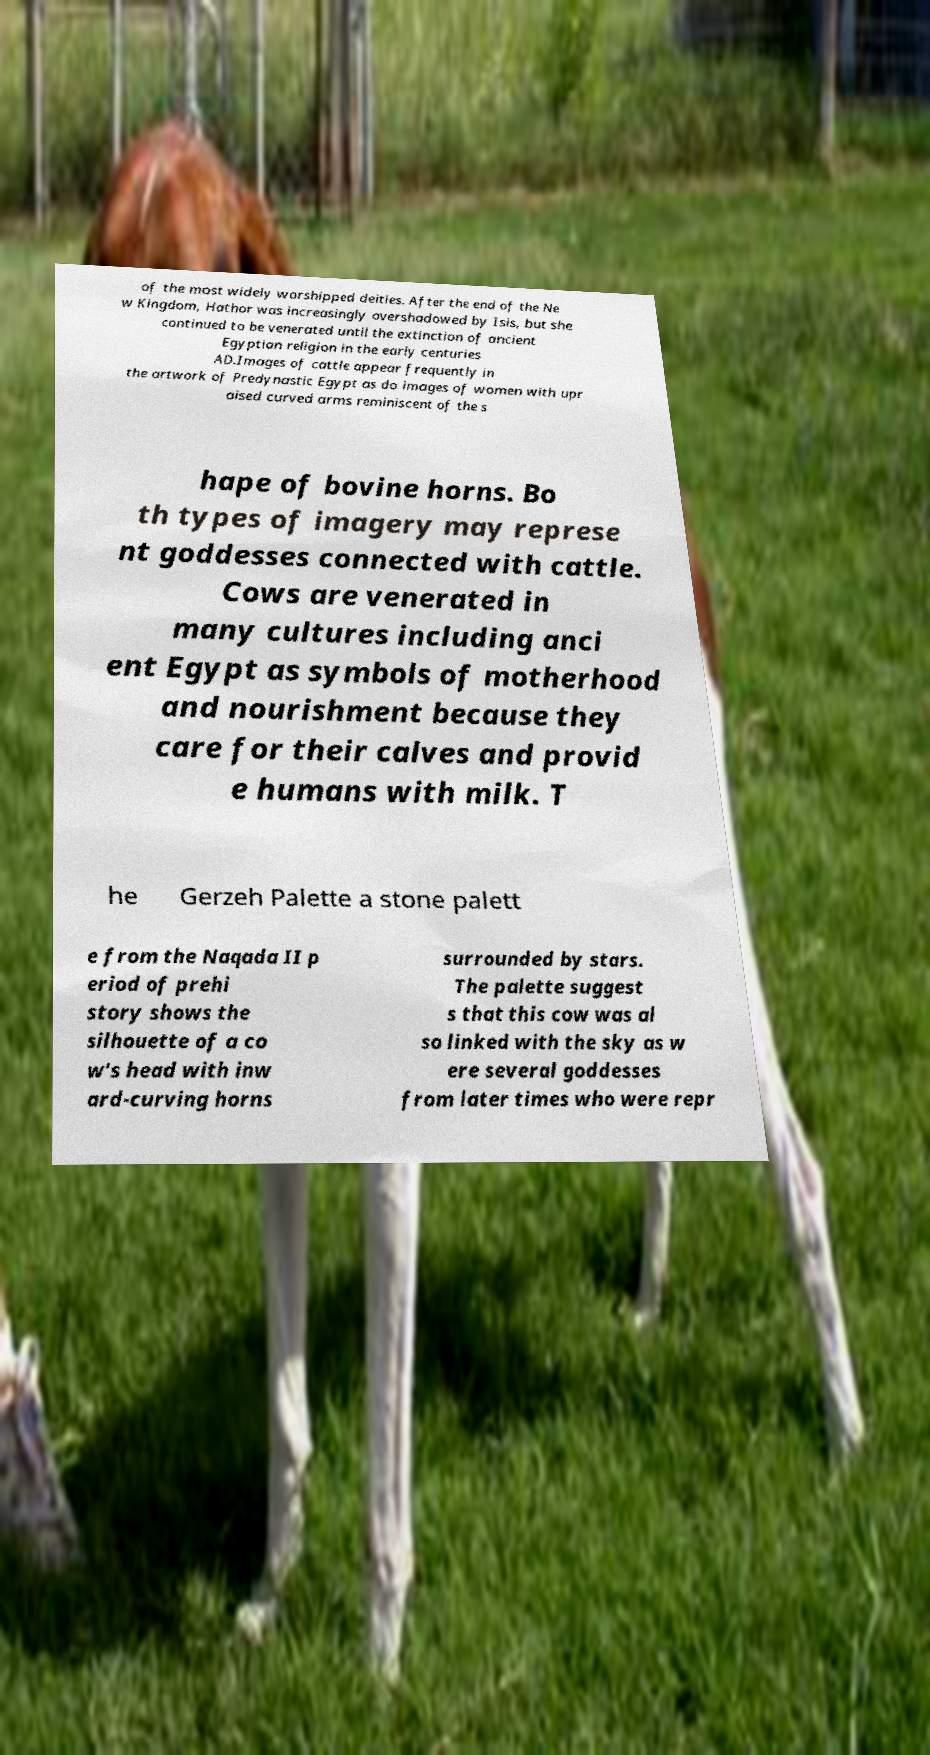For documentation purposes, I need the text within this image transcribed. Could you provide that? of the most widely worshipped deities. After the end of the Ne w Kingdom, Hathor was increasingly overshadowed by Isis, but she continued to be venerated until the extinction of ancient Egyptian religion in the early centuries AD.Images of cattle appear frequently in the artwork of Predynastic Egypt as do images of women with upr aised curved arms reminiscent of the s hape of bovine horns. Bo th types of imagery may represe nt goddesses connected with cattle. Cows are venerated in many cultures including anci ent Egypt as symbols of motherhood and nourishment because they care for their calves and provid e humans with milk. T he Gerzeh Palette a stone palett e from the Naqada II p eriod of prehi story shows the silhouette of a co w's head with inw ard-curving horns surrounded by stars. The palette suggest s that this cow was al so linked with the sky as w ere several goddesses from later times who were repr 